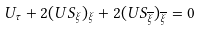<formula> <loc_0><loc_0><loc_500><loc_500>U _ { \tau } + 2 ( U S _ { \xi } ) _ { \xi } + 2 ( U S _ { \overline { \xi } } ) _ { \overline { \xi } } = 0</formula> 